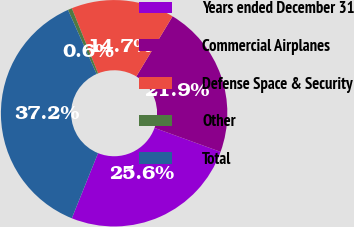Convert chart. <chart><loc_0><loc_0><loc_500><loc_500><pie_chart><fcel>Years ended December 31<fcel>Commercial Airplanes<fcel>Defense Space & Security<fcel>Other<fcel>Total<nl><fcel>25.56%<fcel>21.9%<fcel>14.73%<fcel>0.59%<fcel>37.22%<nl></chart> 